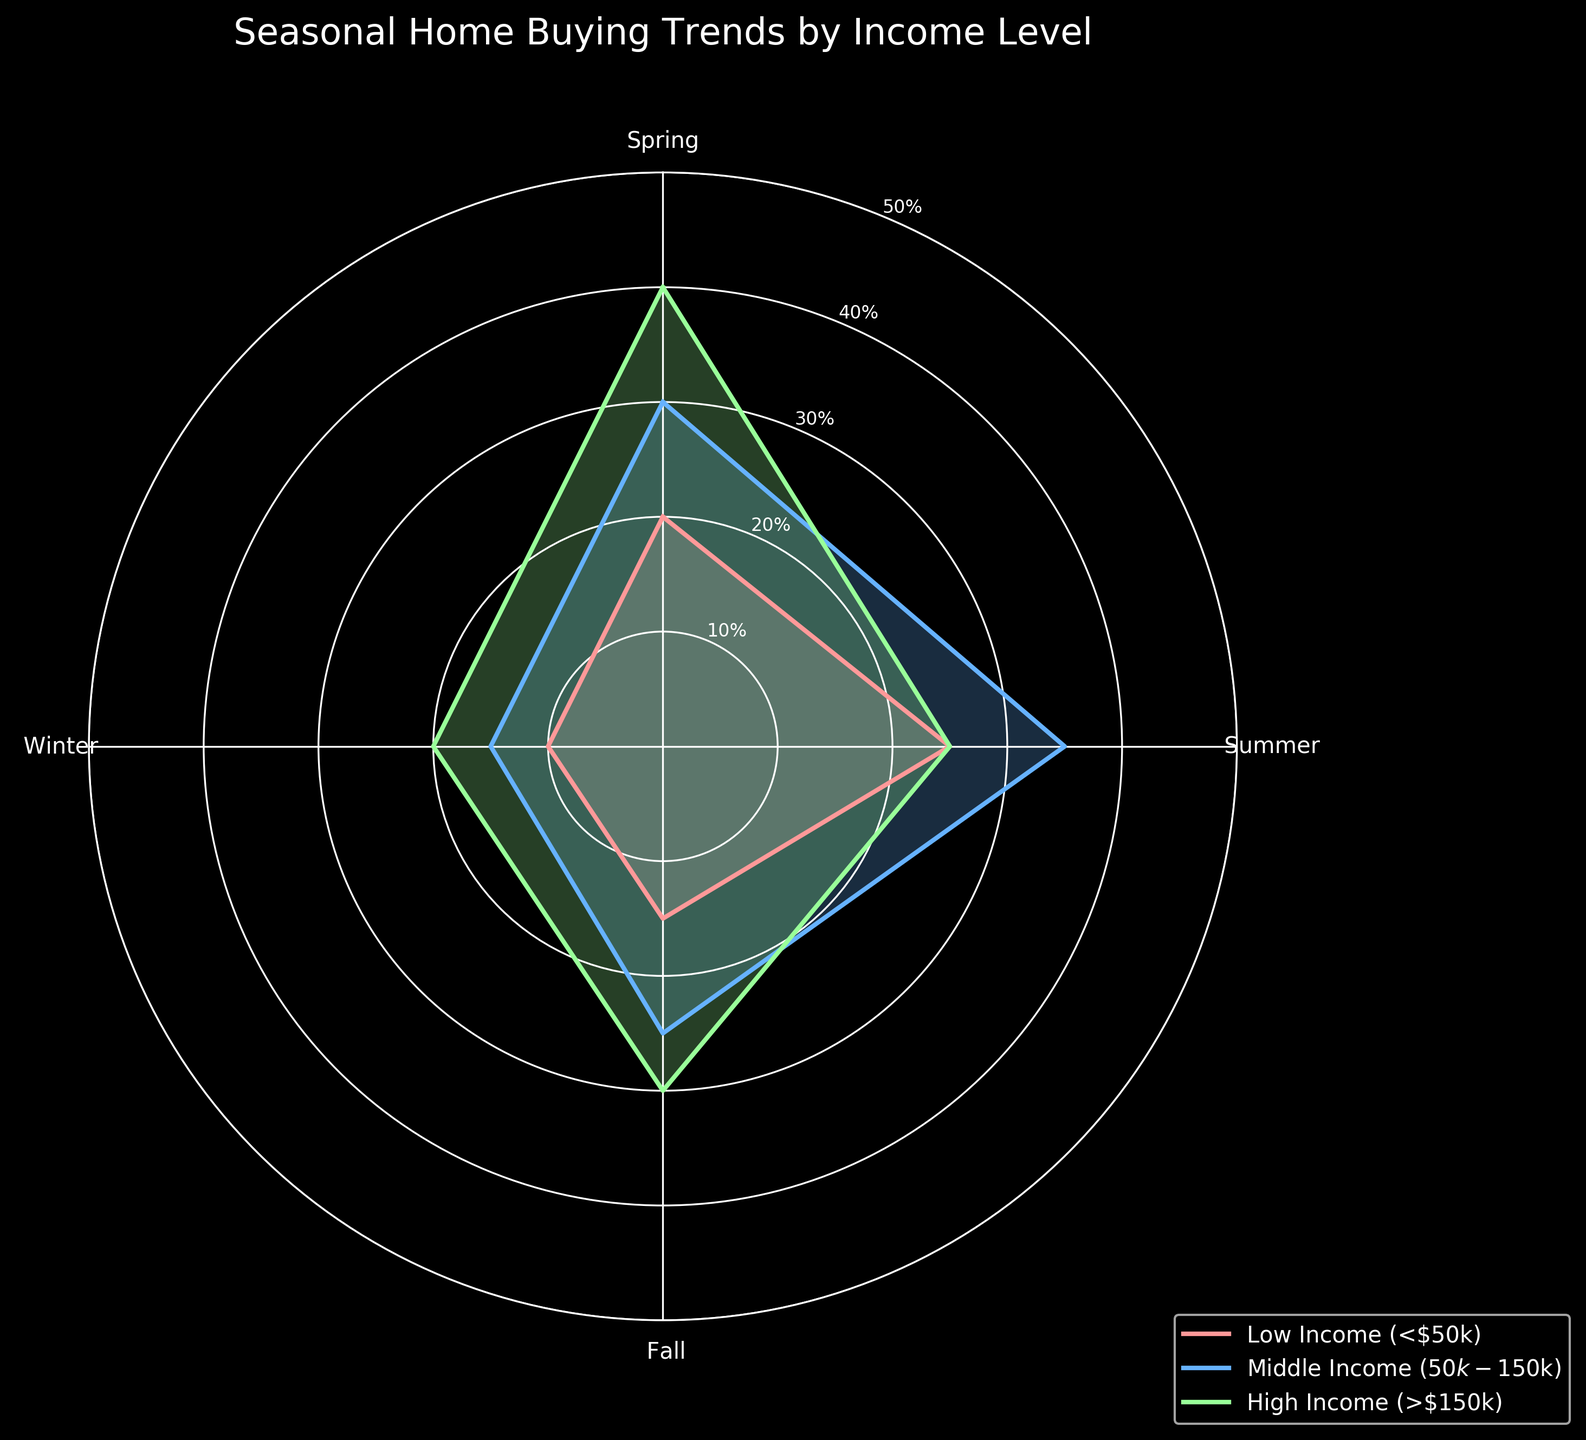What is the title of the chart? The title of the chart is usually placed at the top and is a textual description of the chart's content. In this case, the title is “Seasonal Home Buying Trends by Income Level”.
Answer: Seasonal Home Buying Trends by Income Level How many income levels are represented in the chart? Each distinct color and label in the legend corresponds to an income level. The legend shows three different income levels, each with its own color.
Answer: Three Which season has the highest home-buying percentage for the High Income group? To determine this, look for the highest value on the radar plot in the segment labeled "High Income" in the legend. Each season is a radial line, so find the one with the highest value.
Answer: Spring What is the overall home-buying trend in summer for all income levels combined? Sum the percentages for the summer season across all income levels: Low Income (25) + Middle Income (35) + High Income (25).
Answer: 85% In which season does the Low Income group buy homes the least? Locate the values for each season for the Low Income group and identify the smallest value.
Answer: Winter Compare the Fall home-buying percentages between Middle Income and High Income groups? Identify the percentages for the Fall season for both Middle Income and High Income groups from the chart and compare them.
Answer: Middle Income: 25, High Income: 30 Which group shows the most consistent home-buying trend across all seasons? Examine the variations in percentages for each group across the seasons. The group with the smallest range (difference between highest and lowest values) is the most consistent.
Answer: Low Income What is the average percentage of home-buying across all seasons for the Middle Income group? Add the percentages of the Middle Income group across all seasons and divide by the number of seasons: (30 + 35 + 25 + 15) / 4.
Answer: 26.25% In which season does the home-buying trend decrease from High Income to Low Income? Check each season’s percentage for High Income and Low Income groups and see where the percentage for Low Income is less than that for High Income.
Answer: Spring Is there any season where all income levels show the same percentage of home-buying? Compare the percentages for each season across all income levels to see if any of them match.
Answer: No 